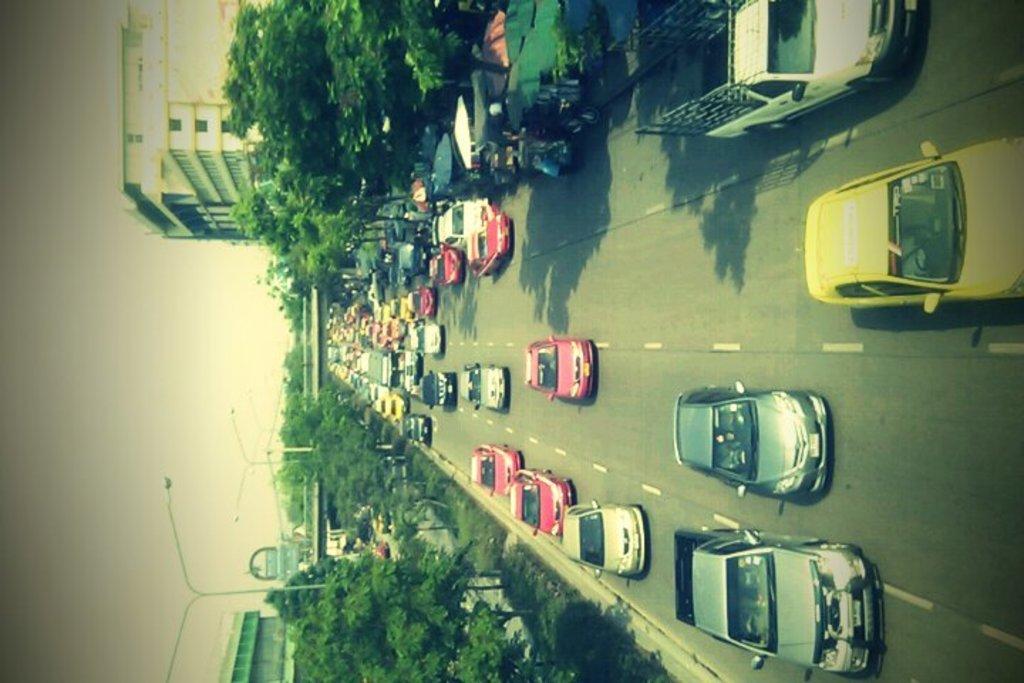Could you give a brief overview of what you see in this image? In this picture there are cars on the road in the center of the image and there are buildings, trees, poles at the top and bottom side of the image. 